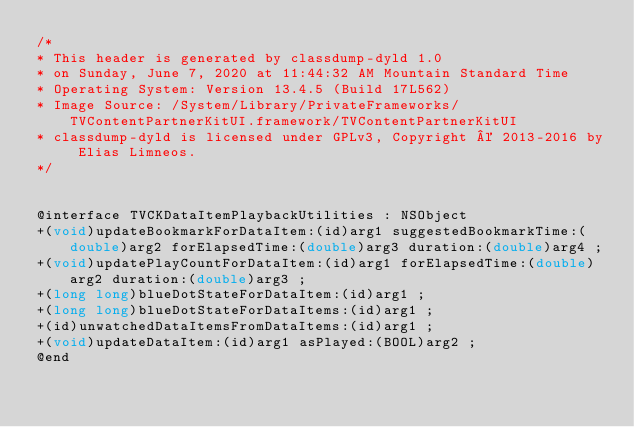Convert code to text. <code><loc_0><loc_0><loc_500><loc_500><_C_>/*
* This header is generated by classdump-dyld 1.0
* on Sunday, June 7, 2020 at 11:44:32 AM Mountain Standard Time
* Operating System: Version 13.4.5 (Build 17L562)
* Image Source: /System/Library/PrivateFrameworks/TVContentPartnerKitUI.framework/TVContentPartnerKitUI
* classdump-dyld is licensed under GPLv3, Copyright © 2013-2016 by Elias Limneos.
*/


@interface TVCKDataItemPlaybackUtilities : NSObject
+(void)updateBookmarkForDataItem:(id)arg1 suggestedBookmarkTime:(double)arg2 forElapsedTime:(double)arg3 duration:(double)arg4 ;
+(void)updatePlayCountForDataItem:(id)arg1 forElapsedTime:(double)arg2 duration:(double)arg3 ;
+(long long)blueDotStateForDataItem:(id)arg1 ;
+(long long)blueDotStateForDataItems:(id)arg1 ;
+(id)unwatchedDataItemsFromDataItems:(id)arg1 ;
+(void)updateDataItem:(id)arg1 asPlayed:(BOOL)arg2 ;
@end

</code> 